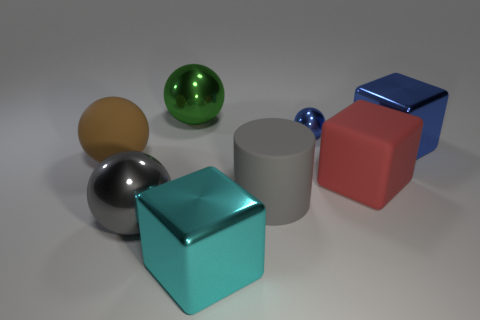Is there a pattern to the arrangement of the objects? While there doesn't seem to be a strict pattern, the objects are arranged in a staggered layout with a mix of sizes and colors distributed across the scene, which provides a balanced and pleasing composition. 